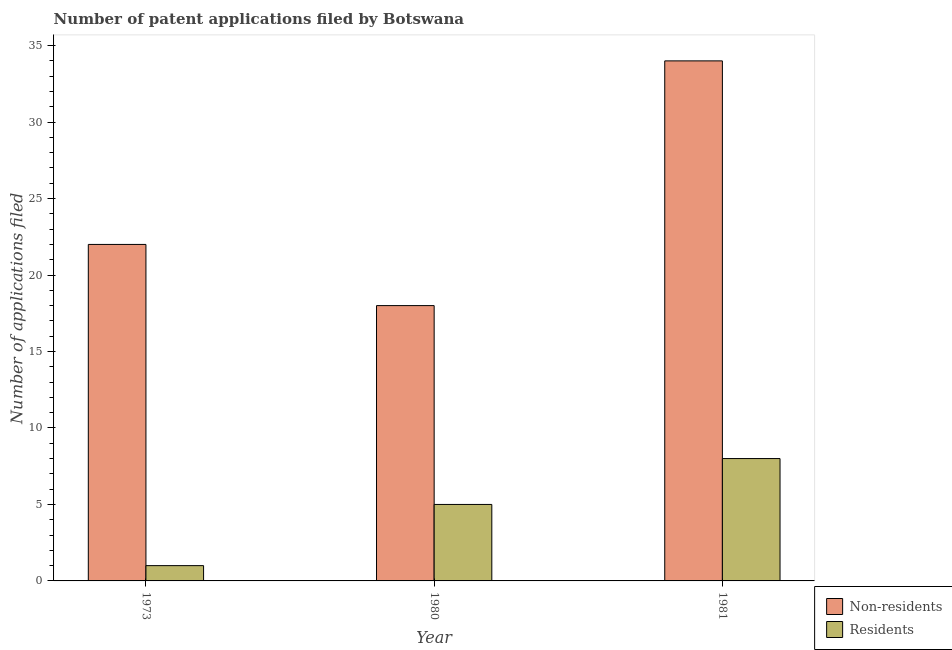How many different coloured bars are there?
Give a very brief answer. 2. How many groups of bars are there?
Keep it short and to the point. 3. How many bars are there on the 2nd tick from the left?
Keep it short and to the point. 2. What is the number of patent applications by residents in 1981?
Make the answer very short. 8. Across all years, what is the maximum number of patent applications by residents?
Your answer should be compact. 8. Across all years, what is the minimum number of patent applications by non residents?
Offer a very short reply. 18. In which year was the number of patent applications by non residents minimum?
Give a very brief answer. 1980. What is the total number of patent applications by non residents in the graph?
Provide a succinct answer. 74. What is the difference between the number of patent applications by residents in 1980 and that in 1981?
Your answer should be compact. -3. What is the difference between the number of patent applications by residents in 1980 and the number of patent applications by non residents in 1973?
Provide a short and direct response. 4. What is the average number of patent applications by residents per year?
Your response must be concise. 4.67. In the year 1980, what is the difference between the number of patent applications by non residents and number of patent applications by residents?
Offer a terse response. 0. What is the ratio of the number of patent applications by non residents in 1973 to that in 1981?
Keep it short and to the point. 0.65. Is the number of patent applications by non residents in 1973 less than that in 1980?
Your answer should be compact. No. Is the difference between the number of patent applications by residents in 1973 and 1981 greater than the difference between the number of patent applications by non residents in 1973 and 1981?
Make the answer very short. No. What is the difference between the highest and the second highest number of patent applications by residents?
Ensure brevity in your answer.  3. What is the difference between the highest and the lowest number of patent applications by non residents?
Provide a short and direct response. 16. What does the 2nd bar from the left in 1980 represents?
Your response must be concise. Residents. What does the 1st bar from the right in 1980 represents?
Provide a short and direct response. Residents. What is the difference between two consecutive major ticks on the Y-axis?
Your answer should be very brief. 5. What is the title of the graph?
Your answer should be compact. Number of patent applications filed by Botswana. What is the label or title of the X-axis?
Offer a terse response. Year. What is the label or title of the Y-axis?
Your answer should be very brief. Number of applications filed. Across all years, what is the maximum Number of applications filed of Residents?
Give a very brief answer. 8. Across all years, what is the minimum Number of applications filed of Non-residents?
Your answer should be very brief. 18. Across all years, what is the minimum Number of applications filed in Residents?
Your response must be concise. 1. What is the total Number of applications filed in Residents in the graph?
Offer a very short reply. 14. What is the difference between the Number of applications filed in Non-residents in 1973 and that in 1981?
Provide a succinct answer. -12. What is the difference between the Number of applications filed of Non-residents in 1973 and the Number of applications filed of Residents in 1980?
Provide a succinct answer. 17. What is the difference between the Number of applications filed of Non-residents in 1980 and the Number of applications filed of Residents in 1981?
Offer a very short reply. 10. What is the average Number of applications filed of Non-residents per year?
Your answer should be very brief. 24.67. What is the average Number of applications filed of Residents per year?
Your answer should be very brief. 4.67. In the year 1973, what is the difference between the Number of applications filed of Non-residents and Number of applications filed of Residents?
Offer a very short reply. 21. In the year 1980, what is the difference between the Number of applications filed in Non-residents and Number of applications filed in Residents?
Offer a terse response. 13. What is the ratio of the Number of applications filed of Non-residents in 1973 to that in 1980?
Offer a very short reply. 1.22. What is the ratio of the Number of applications filed of Non-residents in 1973 to that in 1981?
Ensure brevity in your answer.  0.65. What is the ratio of the Number of applications filed of Residents in 1973 to that in 1981?
Keep it short and to the point. 0.12. What is the ratio of the Number of applications filed of Non-residents in 1980 to that in 1981?
Give a very brief answer. 0.53. What is the difference between the highest and the second highest Number of applications filed of Residents?
Offer a very short reply. 3. 